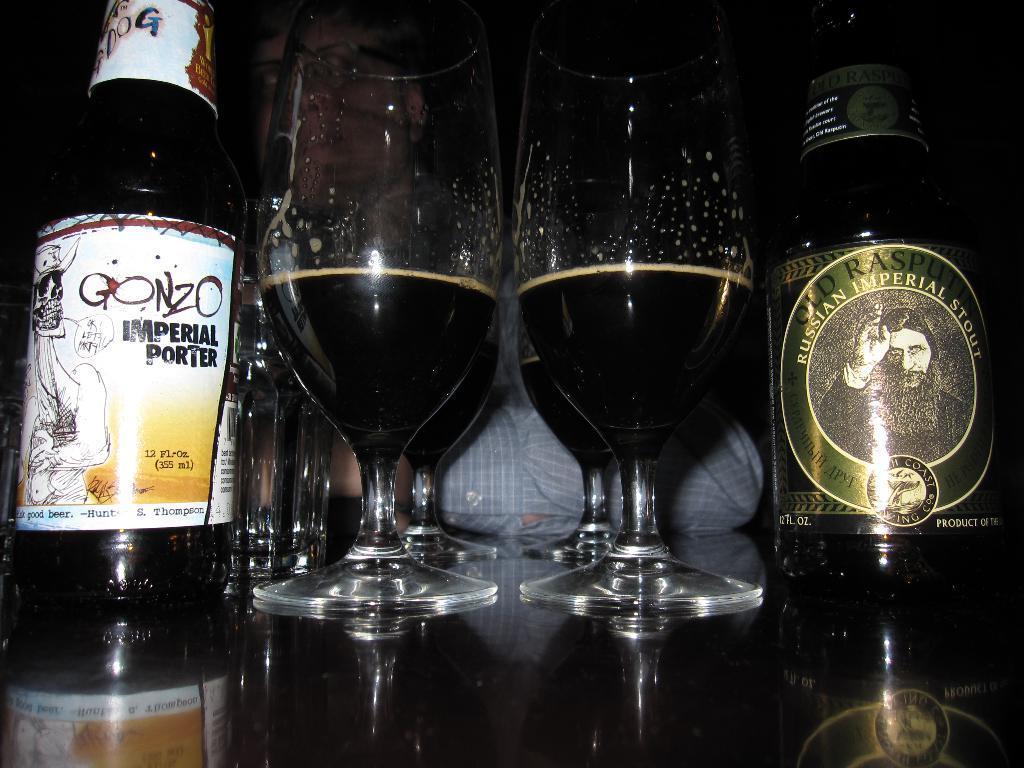In one or two sentences, can you explain what this image depicts? In this image, we can see few wine glasses with liquid and bottles are placed on the surface. Background we can see a person is wearing glasses. 